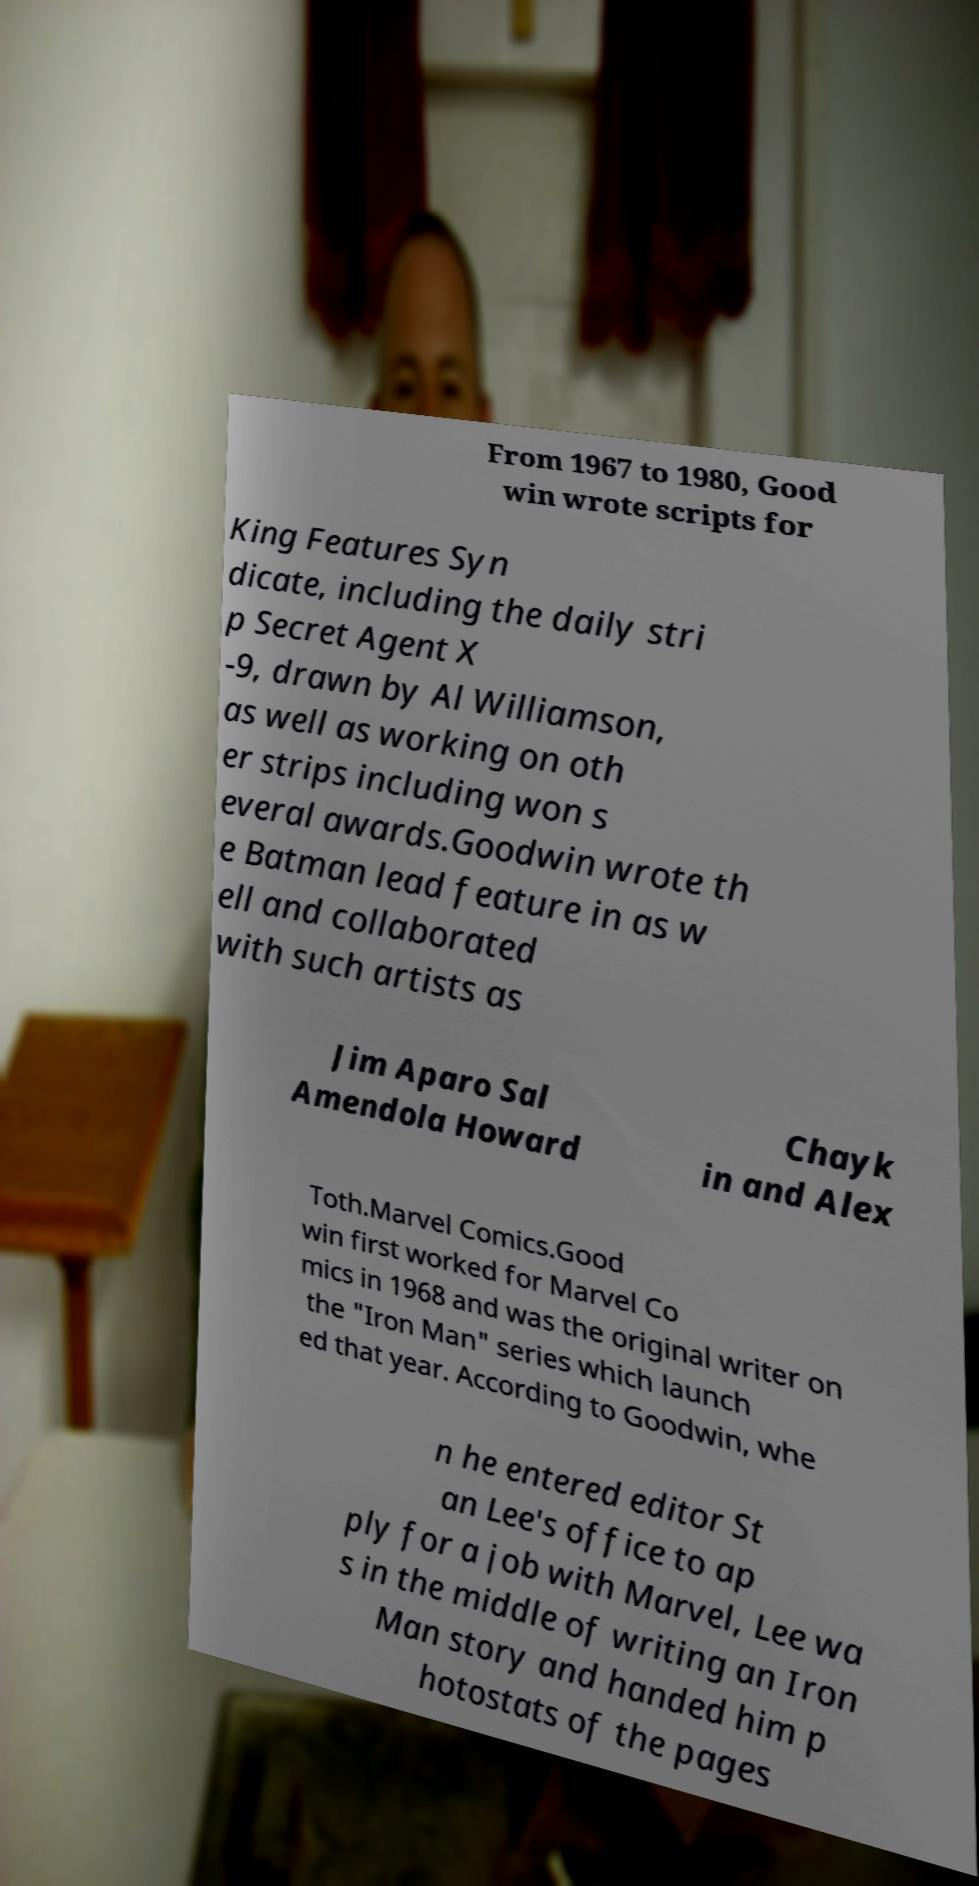Could you extract and type out the text from this image? From 1967 to 1980, Good win wrote scripts for King Features Syn dicate, including the daily stri p Secret Agent X -9, drawn by Al Williamson, as well as working on oth er strips including won s everal awards.Goodwin wrote th e Batman lead feature in as w ell and collaborated with such artists as Jim Aparo Sal Amendola Howard Chayk in and Alex Toth.Marvel Comics.Good win first worked for Marvel Co mics in 1968 and was the original writer on the "Iron Man" series which launch ed that year. According to Goodwin, whe n he entered editor St an Lee's office to ap ply for a job with Marvel, Lee wa s in the middle of writing an Iron Man story and handed him p hotostats of the pages 